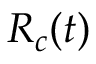Convert formula to latex. <formula><loc_0><loc_0><loc_500><loc_500>R _ { c } ( t )</formula> 